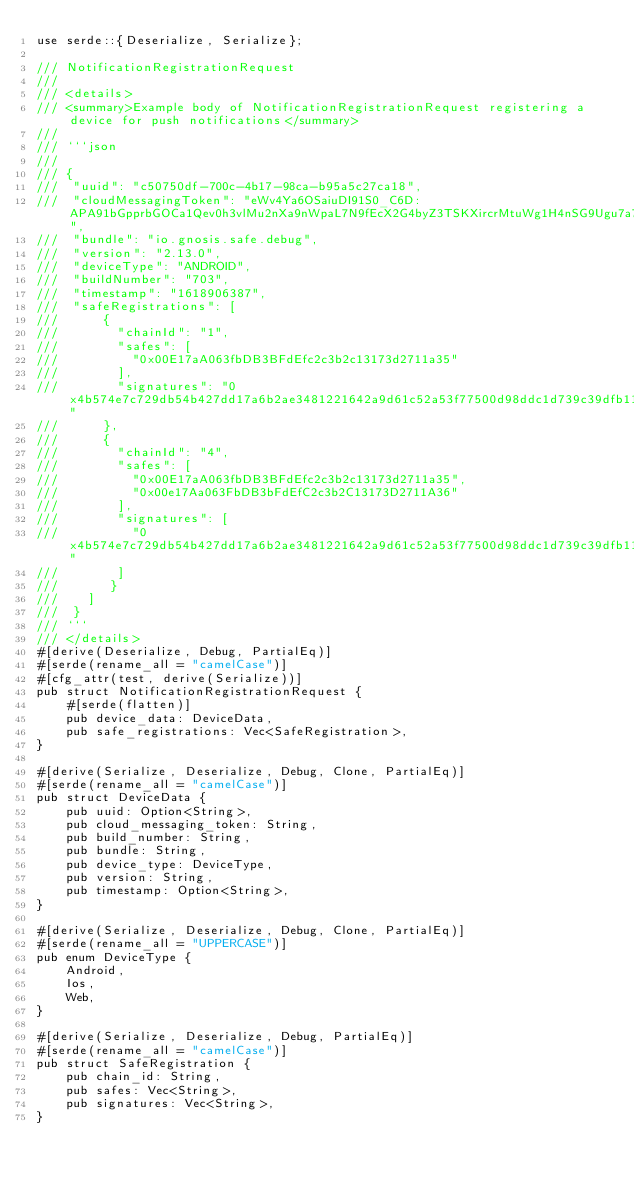<code> <loc_0><loc_0><loc_500><loc_500><_Rust_>use serde::{Deserialize, Serialize};

/// NotificationRegistrationRequest
///
/// <details>
/// <summary>Example body of NotificationRegistrationRequest registering a device for push notifications</summary>
///
/// ```json
/// 
/// {
///  "uuid": "c50750df-700c-4b17-98ca-b95a5c27ca18",
///  "cloudMessagingToken": "eWv4Ya6OSaiuDI91S0_C6D:APA91bGpprbGOCa1Qev0h3vlMu2nXa9nWpaL7N9fEcX2G4byZ3TSKXircrMtuWg1H4nSG9Ugu7a7rgY1eDKAR9UaxgaP1egTRj3taqAfAQblApuiWFfRRkyxdD3N23t7wYi9ZBIXZ88Z",
///  "bundle": "io.gnosis.safe.debug",
///  "version": "2.13.0",
///  "deviceType": "ANDROID",
///  "buildNumber": "703",
///  "timestamp": "1618906387",
///  "safeRegistrations": [
///      {
///        "chainId": "1",
///        "safes": [
///          "0x00E17aA063fbDB3BFdEfc2c3b2c13173d2711a35"
///        ],
///        "signatures": "0x4b574e7c729db54b427dd17a6b2ae3481221642a9d61c52a53f77500d98ddc1d739c39dfb117619fb09a20e3f5070d018e62c37f89fb622ae10b56a6be9af5c11b"
///      },
///      {
///        "chainId": "4",
///        "safes": [
///          "0x00E17aA063fbDB3BFdEfc2c3b2c13173d2711a35",
///          "0x00e17Aa063FbDB3bFdEfC2c3b2C13173D2711A36"
///        ],
///        "signatures": [
///          "0x4b574e7c729db54b427dd17a6b2ae3481221642a9d61c52a53f77500d98ddc1d739c39dfb117619fb09a20e3f5070d018e62c37f89fb622ae10b56a6be9af5c11b"
///        ]
///       }
///    ]
///  }
/// ```
/// </details>
#[derive(Deserialize, Debug, PartialEq)]
#[serde(rename_all = "camelCase")]
#[cfg_attr(test, derive(Serialize))]
pub struct NotificationRegistrationRequest {
    #[serde(flatten)]
    pub device_data: DeviceData,
    pub safe_registrations: Vec<SafeRegistration>,
}

#[derive(Serialize, Deserialize, Debug, Clone, PartialEq)]
#[serde(rename_all = "camelCase")]
pub struct DeviceData {
    pub uuid: Option<String>,
    pub cloud_messaging_token: String,
    pub build_number: String,
    pub bundle: String,
    pub device_type: DeviceType,
    pub version: String,
    pub timestamp: Option<String>,
}

#[derive(Serialize, Deserialize, Debug, Clone, PartialEq)]
#[serde(rename_all = "UPPERCASE")]
pub enum DeviceType {
    Android,
    Ios,
    Web,
}

#[derive(Serialize, Deserialize, Debug, PartialEq)]
#[serde(rename_all = "camelCase")]
pub struct SafeRegistration {
    pub chain_id: String,
    pub safes: Vec<String>,
    pub signatures: Vec<String>,
}
</code> 